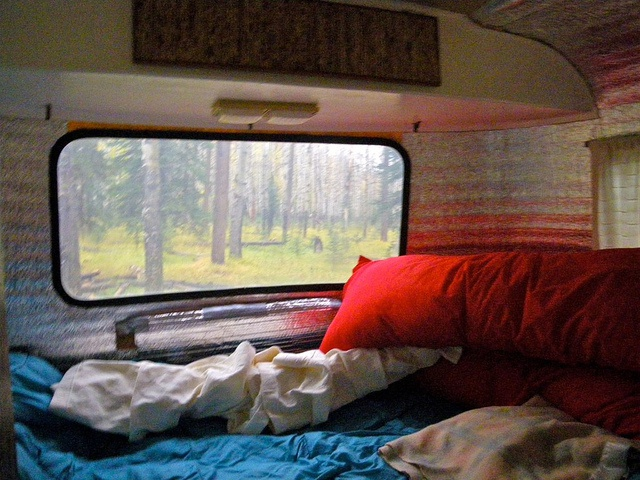Describe the objects in this image and their specific colors. I can see a bed in black, maroon, gray, and darkgray tones in this image. 